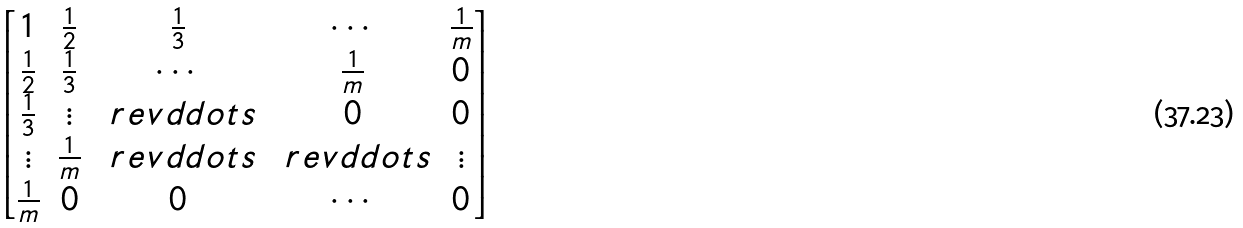Convert formula to latex. <formula><loc_0><loc_0><loc_500><loc_500>\begin{bmatrix} 1 & \frac { 1 } { 2 } & \frac { 1 } { 3 } & \cdots & \frac { 1 } { m } \\ \frac { 1 } { 2 } & \frac { 1 } { 3 } & \cdots & \frac { 1 } { m } & 0 \\ \frac { 1 } { 3 } & \vdots & \ r e v d d o t s & 0 & 0 \\ \vdots & \frac { 1 } { m } & \ r e v d d o t s & \ r e v d d o t s & \vdots \\ \frac { 1 } { m } & 0 & 0 & \cdots & 0 \end{bmatrix}</formula> 